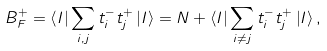<formula> <loc_0><loc_0><loc_500><loc_500>B _ { F } ^ { + } = \left \langle I \right | \sum _ { i , j } t _ { i } ^ { - } t _ { j } ^ { + } \left | I \right \rangle = N + \left \langle I \right | \sum _ { i \neq j } t _ { i } ^ { - } t _ { j } ^ { + } \left | I \right \rangle ,</formula> 